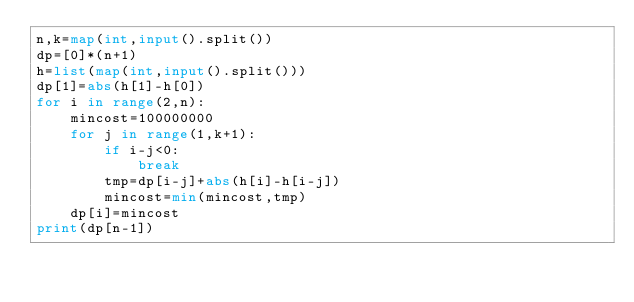Convert code to text. <code><loc_0><loc_0><loc_500><loc_500><_Python_>n,k=map(int,input().split())
dp=[0]*(n+1)
h=list(map(int,input().split()))
dp[1]=abs(h[1]-h[0])
for i in range(2,n):
    mincost=100000000
    for j in range(1,k+1):
        if i-j<0:
            break
        tmp=dp[i-j]+abs(h[i]-h[i-j])
        mincost=min(mincost,tmp)
    dp[i]=mincost
print(dp[n-1])</code> 